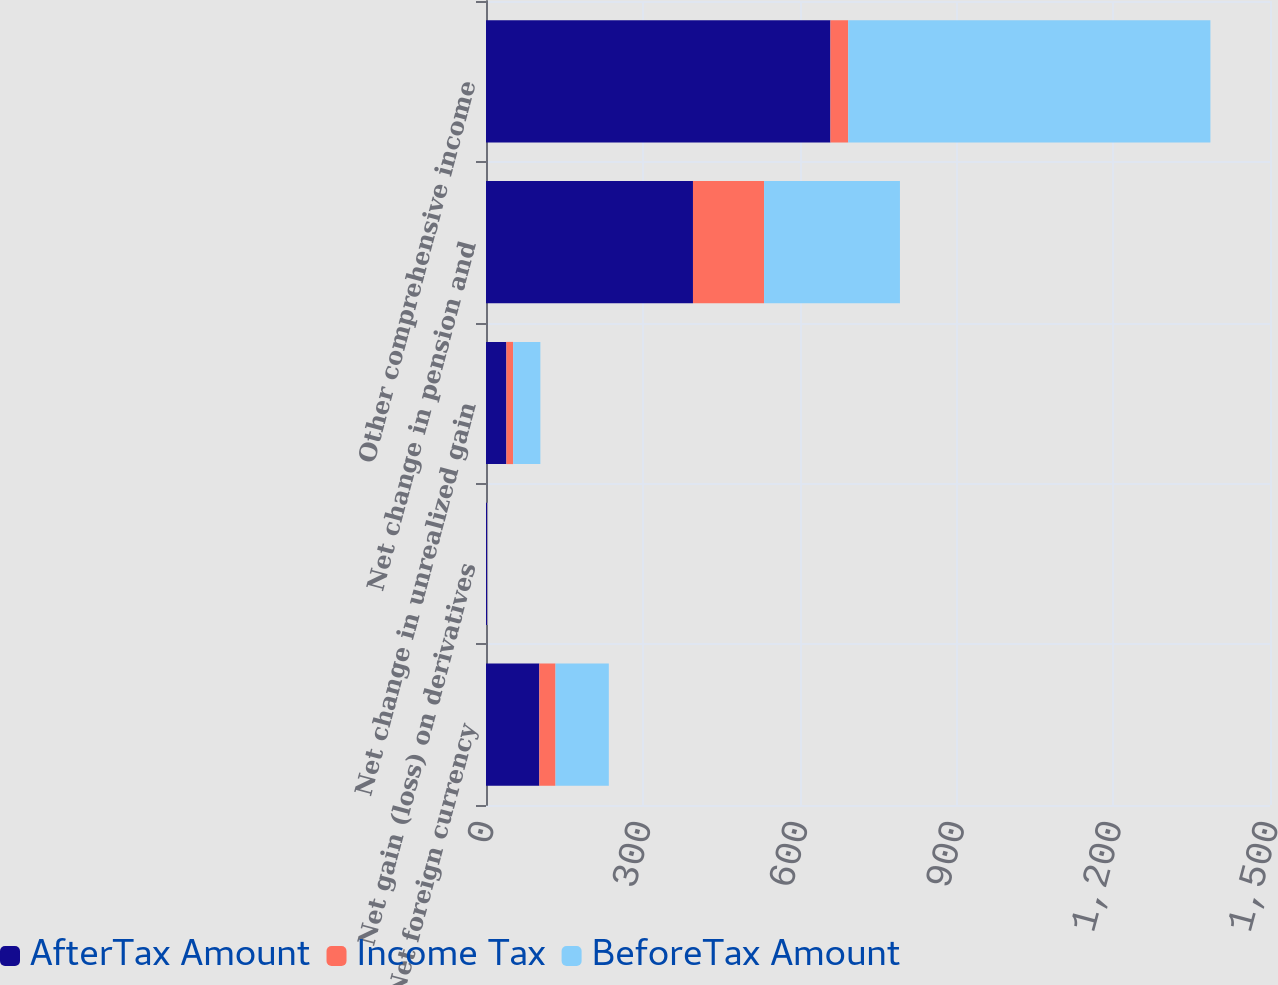Convert chart. <chart><loc_0><loc_0><loc_500><loc_500><stacked_bar_chart><ecel><fcel>Net foreign currency<fcel>Net gain (loss) on derivatives<fcel>Net change in unrealized gain<fcel>Net change in pension and<fcel>Other comprehensive income<nl><fcel>AfterTax Amount<fcel>102<fcel>2<fcel>39<fcel>396<fcel>659<nl><fcel>Income Tax<fcel>31<fcel>1<fcel>13<fcel>136<fcel>34<nl><fcel>BeforeTax Amount<fcel>102<fcel>1<fcel>52<fcel>260<fcel>693<nl></chart> 